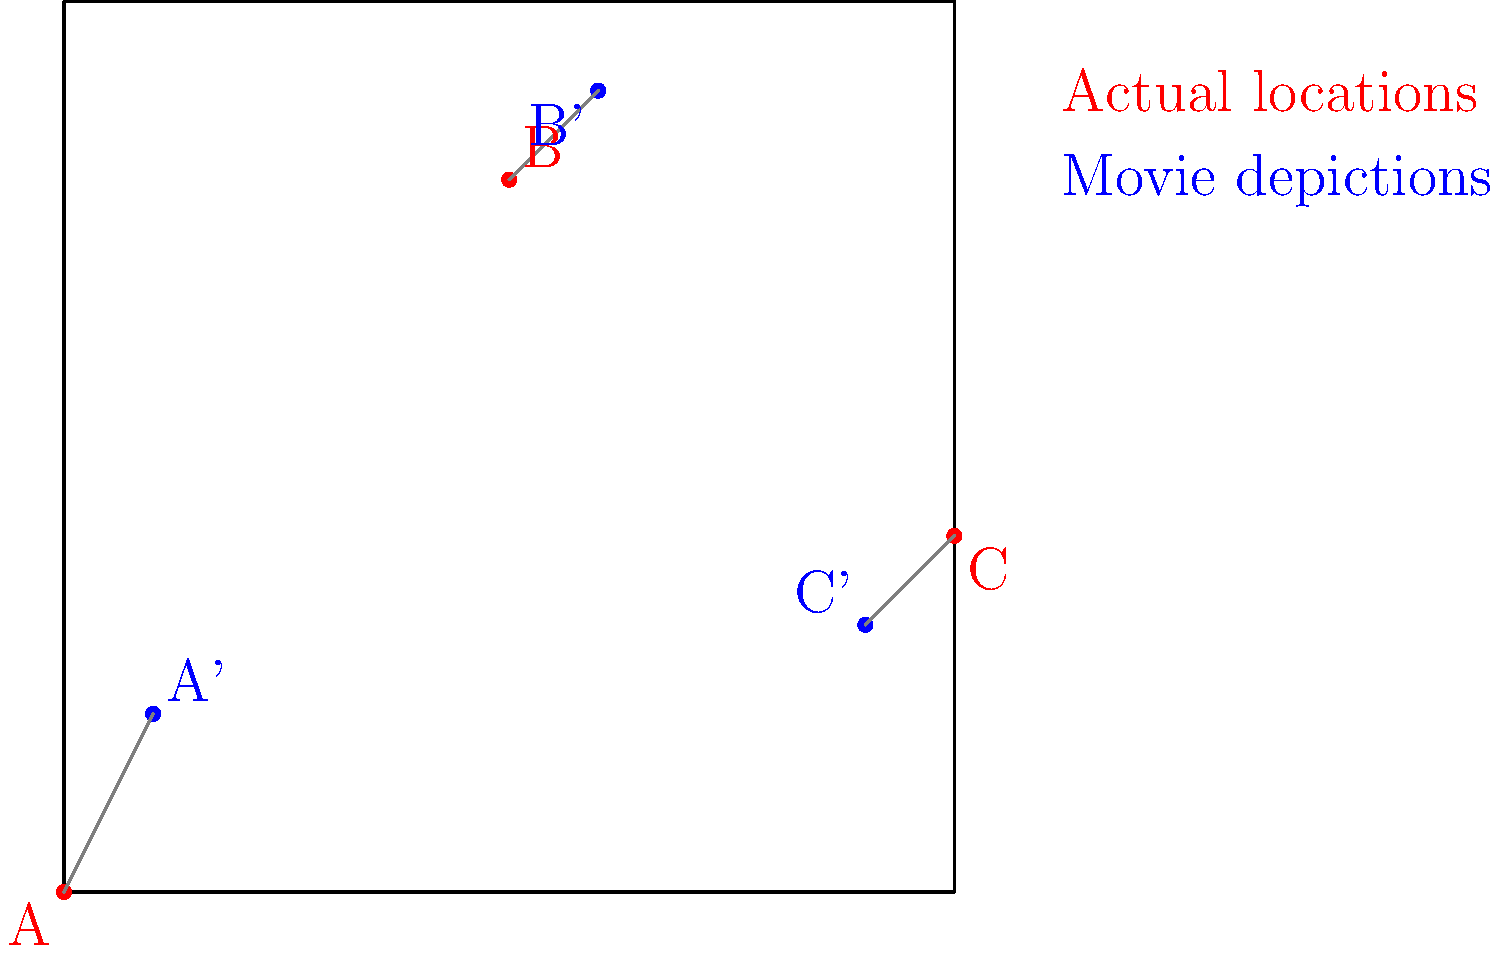Based on the map showing actual historical battle locations (red dots) and their movie depictions (blue dots), which battle scene in the film demonstrates the greatest geographical inaccuracy? To determine which battle scene shows the greatest geographical inaccuracy, we need to compare the distances between each pair of actual and depicted locations:

1. For Battle A:
   - Actual location: A (0,0)
   - Movie depiction: A' (10,20)
   - Distance = $\sqrt{(10-0)^2 + (20-0)^2} = \sqrt{500} \approx 22.36$

2. For Battle B:
   - Actual location: B (50,80)
   - Movie depiction: B' (60,90)
   - Distance = $\sqrt{(60-50)^2 + (90-80)^2} = \sqrt{200} \approx 14.14$

3. For Battle C:
   - Actual location: C (100,40)
   - Movie depiction: C' (90,30)
   - Distance = $\sqrt{(90-100)^2 + (30-40)^2} = \sqrt{200} \approx 14.14$

The battle scene with the greatest geographical inaccuracy is the one with the largest distance between its actual and depicted locations. In this case, it's Battle A with a distance of approximately 22.36 units.
Answer: Battle A 